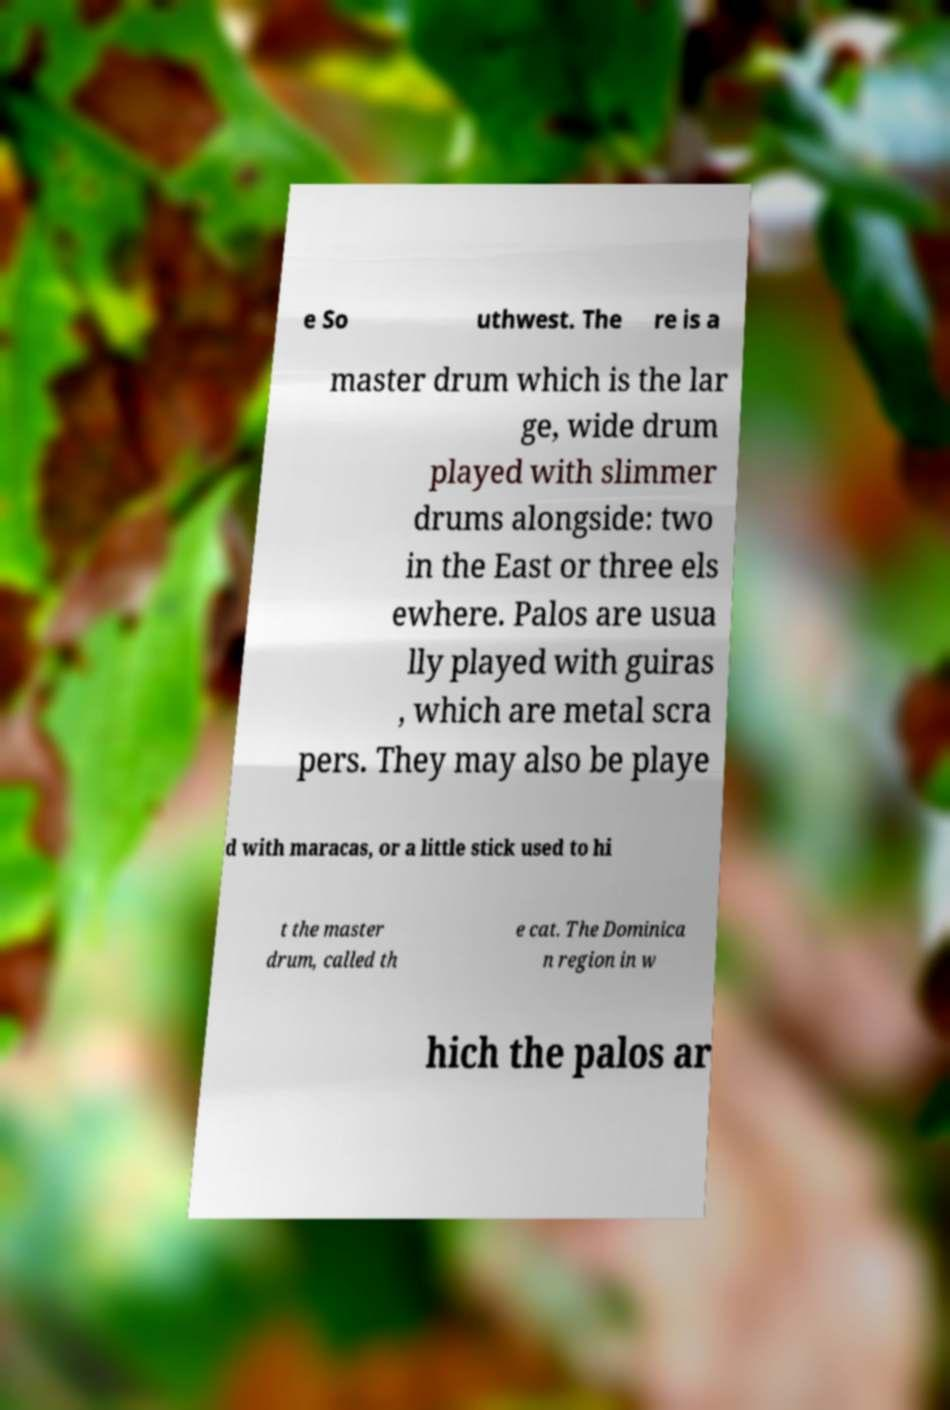Could you assist in decoding the text presented in this image and type it out clearly? e So uthwest. The re is a master drum which is the lar ge, wide drum played with slimmer drums alongside: two in the East or three els ewhere. Palos are usua lly played with guiras , which are metal scra pers. They may also be playe d with maracas, or a little stick used to hi t the master drum, called th e cat. The Dominica n region in w hich the palos ar 